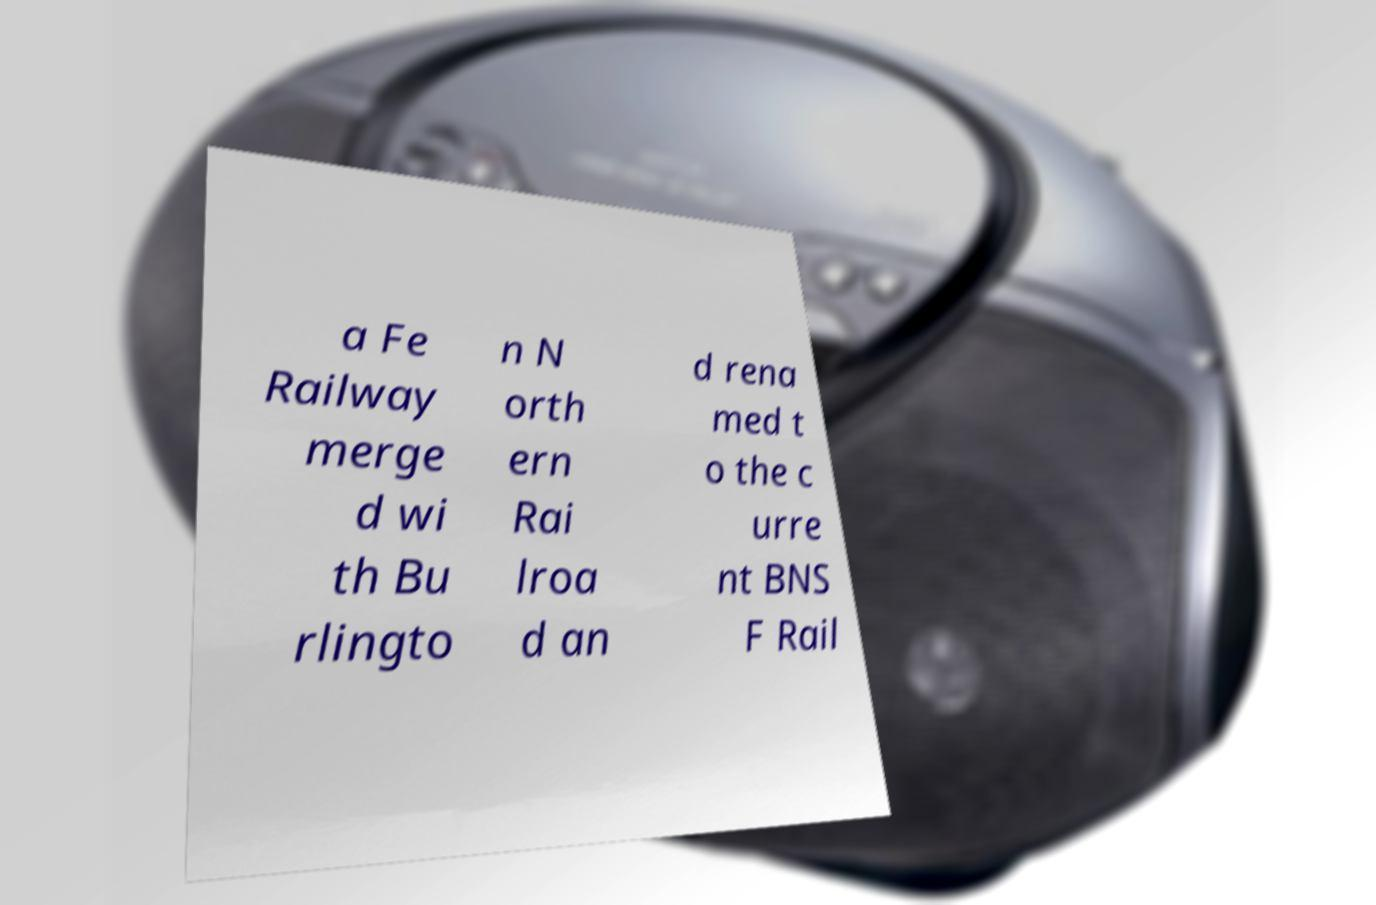Please read and relay the text visible in this image. What does it say? a Fe Railway merge d wi th Bu rlingto n N orth ern Rai lroa d an d rena med t o the c urre nt BNS F Rail 